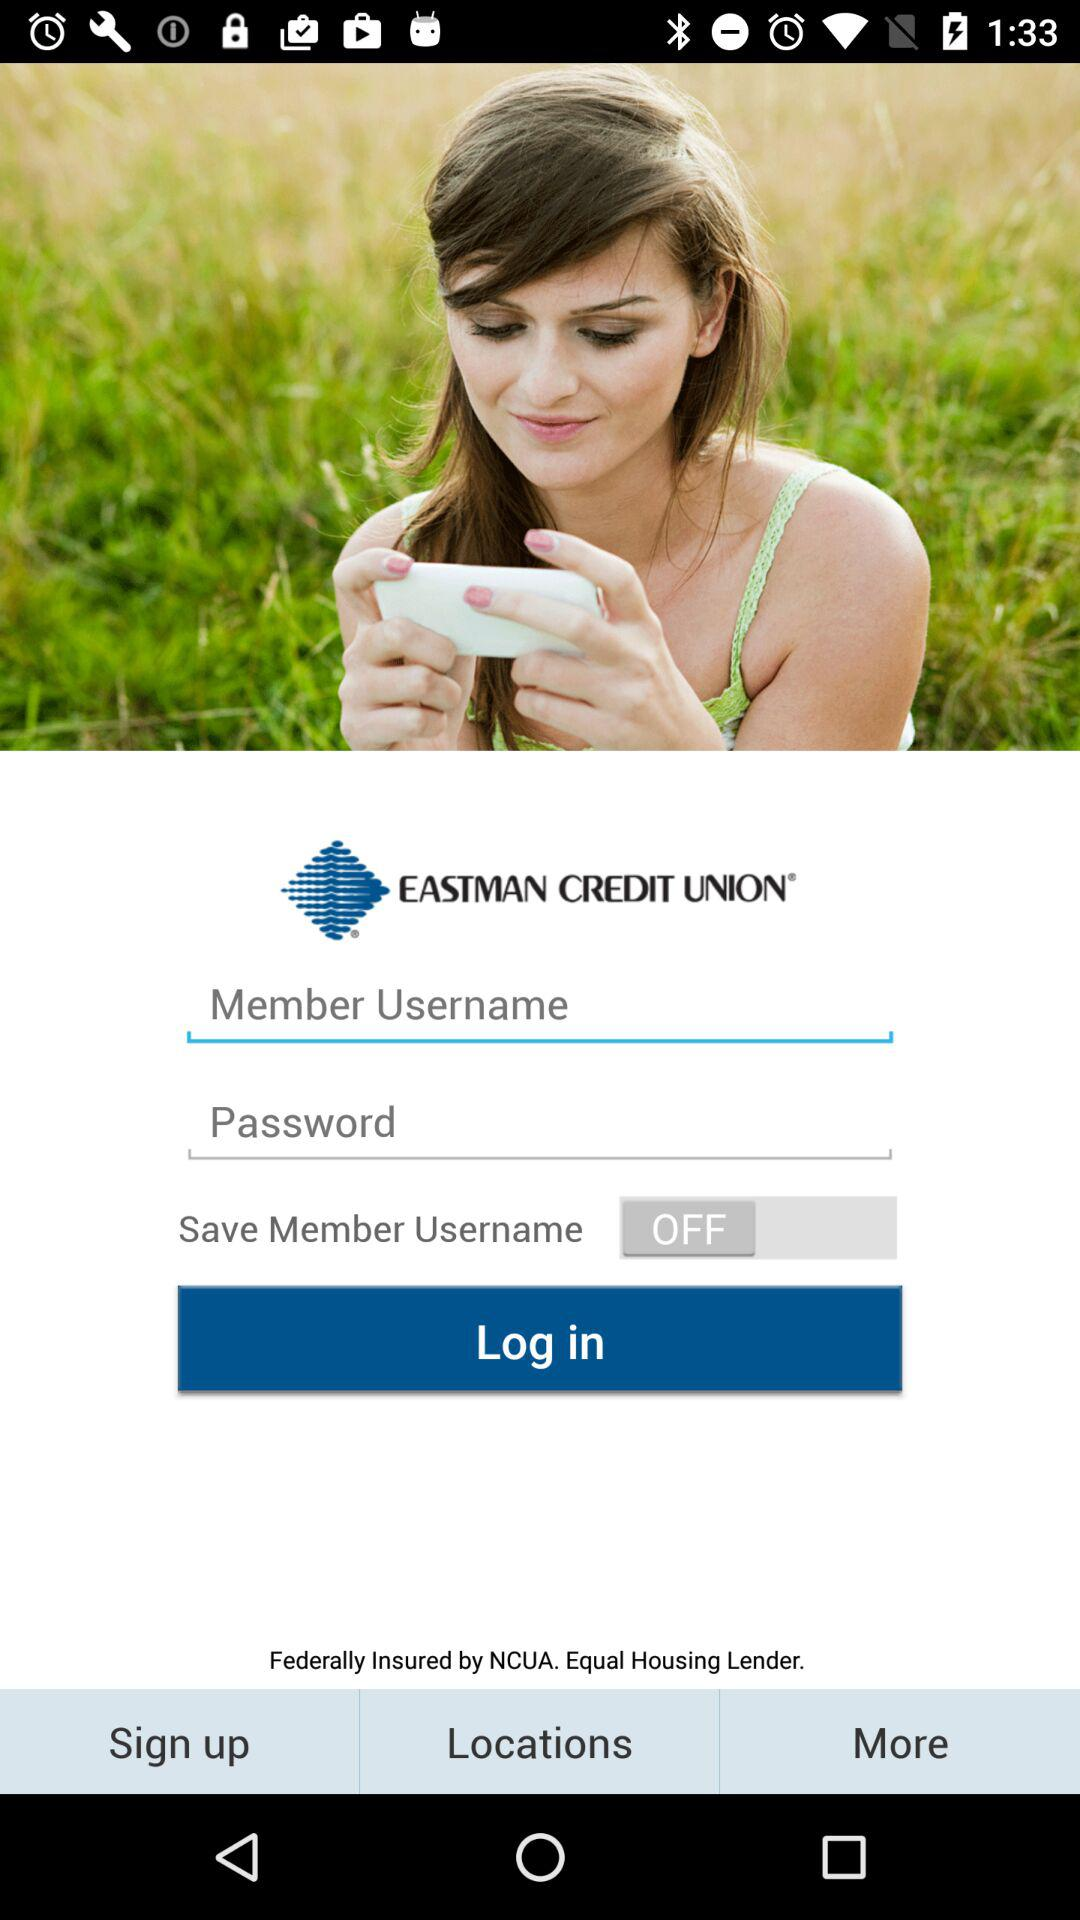What is the status of "Save Member Username"? The status of "Save Member Username" is "off". 